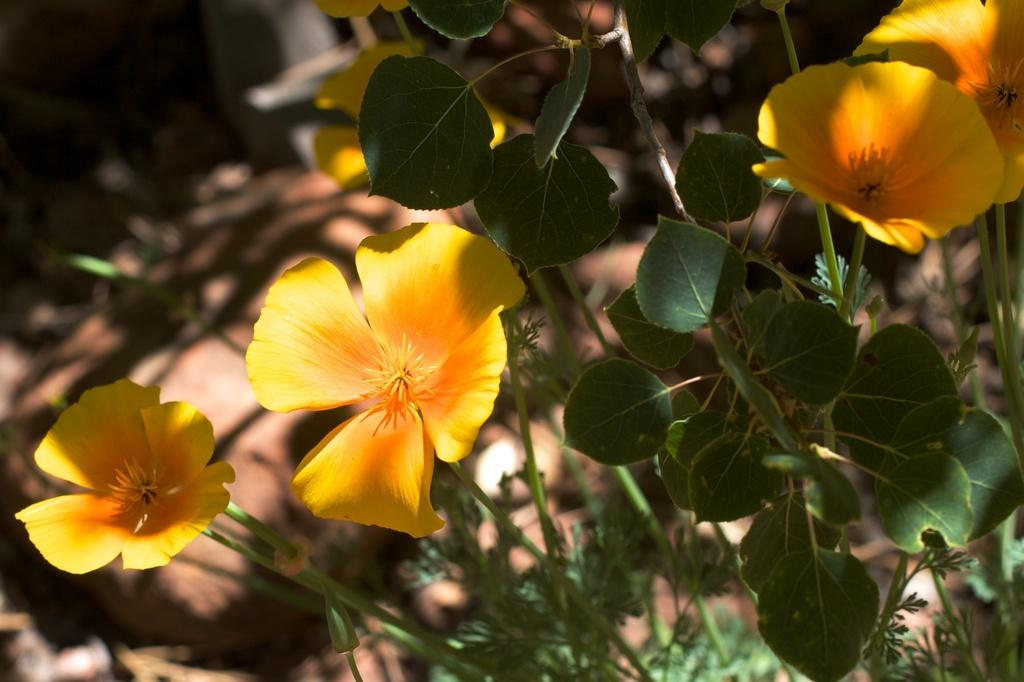What color are the flowers in the image? The flowers in the image are yellow. What color are the leaves in the image? The leaves in the image are green. Where is the secretary located in the image? There is no secretary present in the image; it features only flowers and leaves. What type of muscle can be seen in the image? There are no muscles present in the image; it features only flowers and leaves. 